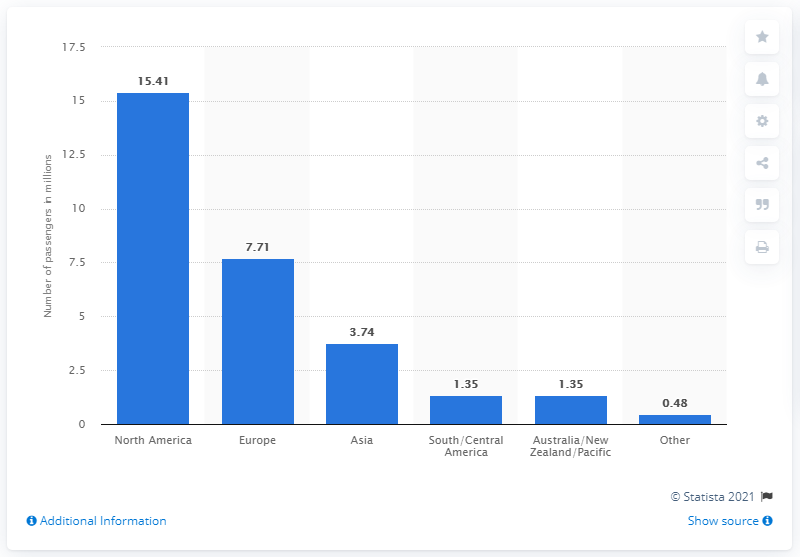Specify some key components in this picture. In 2019, the highest number of cruise passengers originated from North America. In 2019, the total number of cruise passengers in Europe was 7.71 million. 